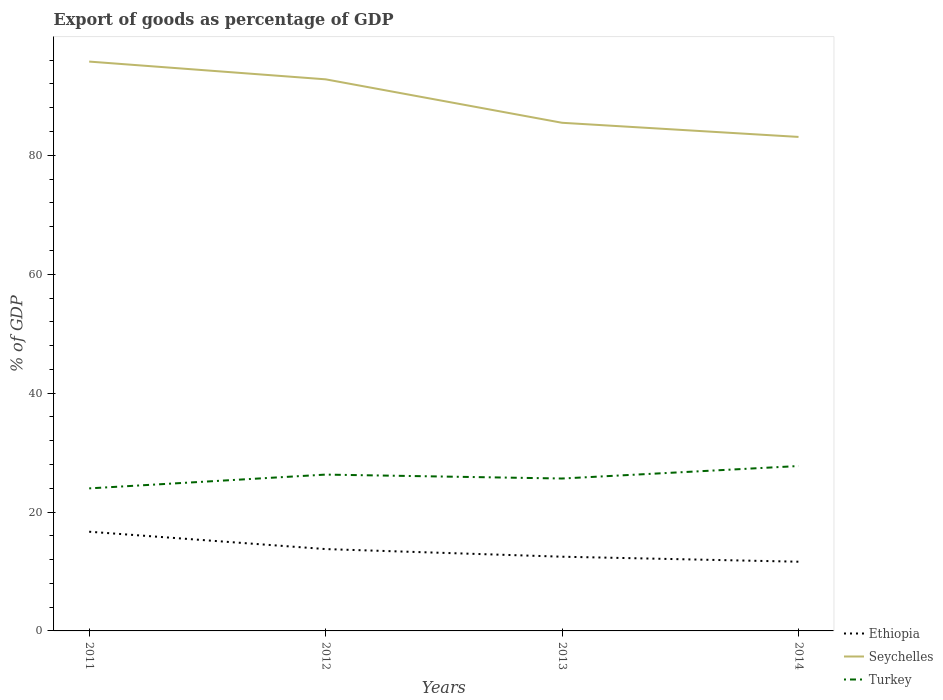Does the line corresponding to Seychelles intersect with the line corresponding to Ethiopia?
Your answer should be compact. No. Across all years, what is the maximum export of goods as percentage of GDP in Turkey?
Provide a succinct answer. 23.98. In which year was the export of goods as percentage of GDP in Turkey maximum?
Your answer should be compact. 2011. What is the total export of goods as percentage of GDP in Ethiopia in the graph?
Ensure brevity in your answer.  4.2. What is the difference between the highest and the second highest export of goods as percentage of GDP in Ethiopia?
Offer a very short reply. 5.05. Is the export of goods as percentage of GDP in Turkey strictly greater than the export of goods as percentage of GDP in Ethiopia over the years?
Your response must be concise. No. How many lines are there?
Give a very brief answer. 3. Does the graph contain any zero values?
Give a very brief answer. No. How many legend labels are there?
Offer a very short reply. 3. What is the title of the graph?
Provide a succinct answer. Export of goods as percentage of GDP. Does "Middle East & North Africa (developing only)" appear as one of the legend labels in the graph?
Provide a succinct answer. No. What is the label or title of the Y-axis?
Give a very brief answer. % of GDP. What is the % of GDP in Ethiopia in 2011?
Provide a short and direct response. 16.69. What is the % of GDP of Seychelles in 2011?
Provide a succinct answer. 95.77. What is the % of GDP of Turkey in 2011?
Ensure brevity in your answer.  23.98. What is the % of GDP of Ethiopia in 2012?
Provide a succinct answer. 13.77. What is the % of GDP in Seychelles in 2012?
Keep it short and to the point. 92.79. What is the % of GDP of Turkey in 2012?
Offer a very short reply. 26.3. What is the % of GDP in Ethiopia in 2013?
Provide a succinct answer. 12.48. What is the % of GDP of Seychelles in 2013?
Make the answer very short. 85.48. What is the % of GDP in Turkey in 2013?
Your answer should be compact. 25.64. What is the % of GDP of Ethiopia in 2014?
Offer a very short reply. 11.64. What is the % of GDP in Seychelles in 2014?
Give a very brief answer. 83.1. What is the % of GDP in Turkey in 2014?
Your answer should be compact. 27.74. Across all years, what is the maximum % of GDP of Ethiopia?
Keep it short and to the point. 16.69. Across all years, what is the maximum % of GDP in Seychelles?
Offer a terse response. 95.77. Across all years, what is the maximum % of GDP of Turkey?
Ensure brevity in your answer.  27.74. Across all years, what is the minimum % of GDP in Ethiopia?
Your answer should be compact. 11.64. Across all years, what is the minimum % of GDP in Seychelles?
Provide a succinct answer. 83.1. Across all years, what is the minimum % of GDP in Turkey?
Provide a succinct answer. 23.98. What is the total % of GDP in Ethiopia in the graph?
Your answer should be very brief. 54.58. What is the total % of GDP in Seychelles in the graph?
Your response must be concise. 357.13. What is the total % of GDP in Turkey in the graph?
Keep it short and to the point. 103.65. What is the difference between the % of GDP of Ethiopia in 2011 and that in 2012?
Your response must be concise. 2.92. What is the difference between the % of GDP of Seychelles in 2011 and that in 2012?
Your response must be concise. 2.98. What is the difference between the % of GDP of Turkey in 2011 and that in 2012?
Keep it short and to the point. -2.32. What is the difference between the % of GDP of Ethiopia in 2011 and that in 2013?
Provide a succinct answer. 4.2. What is the difference between the % of GDP of Seychelles in 2011 and that in 2013?
Your answer should be very brief. 10.29. What is the difference between the % of GDP of Turkey in 2011 and that in 2013?
Give a very brief answer. -1.66. What is the difference between the % of GDP of Ethiopia in 2011 and that in 2014?
Keep it short and to the point. 5.05. What is the difference between the % of GDP of Seychelles in 2011 and that in 2014?
Your answer should be very brief. 12.67. What is the difference between the % of GDP of Turkey in 2011 and that in 2014?
Your response must be concise. -3.76. What is the difference between the % of GDP of Ethiopia in 2012 and that in 2013?
Provide a succinct answer. 1.28. What is the difference between the % of GDP in Seychelles in 2012 and that in 2013?
Make the answer very short. 7.31. What is the difference between the % of GDP in Turkey in 2012 and that in 2013?
Your answer should be very brief. 0.66. What is the difference between the % of GDP of Ethiopia in 2012 and that in 2014?
Offer a very short reply. 2.13. What is the difference between the % of GDP of Seychelles in 2012 and that in 2014?
Make the answer very short. 9.69. What is the difference between the % of GDP in Turkey in 2012 and that in 2014?
Your response must be concise. -1.44. What is the difference between the % of GDP of Ethiopia in 2013 and that in 2014?
Your answer should be very brief. 0.84. What is the difference between the % of GDP in Seychelles in 2013 and that in 2014?
Your response must be concise. 2.38. What is the difference between the % of GDP of Turkey in 2013 and that in 2014?
Give a very brief answer. -2.1. What is the difference between the % of GDP of Ethiopia in 2011 and the % of GDP of Seychelles in 2012?
Your response must be concise. -76.1. What is the difference between the % of GDP of Ethiopia in 2011 and the % of GDP of Turkey in 2012?
Your answer should be very brief. -9.61. What is the difference between the % of GDP of Seychelles in 2011 and the % of GDP of Turkey in 2012?
Offer a terse response. 69.47. What is the difference between the % of GDP in Ethiopia in 2011 and the % of GDP in Seychelles in 2013?
Your answer should be compact. -68.79. What is the difference between the % of GDP in Ethiopia in 2011 and the % of GDP in Turkey in 2013?
Offer a very short reply. -8.95. What is the difference between the % of GDP of Seychelles in 2011 and the % of GDP of Turkey in 2013?
Your answer should be compact. 70.13. What is the difference between the % of GDP of Ethiopia in 2011 and the % of GDP of Seychelles in 2014?
Your answer should be very brief. -66.41. What is the difference between the % of GDP in Ethiopia in 2011 and the % of GDP in Turkey in 2014?
Make the answer very short. -11.05. What is the difference between the % of GDP in Seychelles in 2011 and the % of GDP in Turkey in 2014?
Keep it short and to the point. 68.03. What is the difference between the % of GDP of Ethiopia in 2012 and the % of GDP of Seychelles in 2013?
Give a very brief answer. -71.71. What is the difference between the % of GDP in Ethiopia in 2012 and the % of GDP in Turkey in 2013?
Make the answer very short. -11.87. What is the difference between the % of GDP in Seychelles in 2012 and the % of GDP in Turkey in 2013?
Give a very brief answer. 67.15. What is the difference between the % of GDP of Ethiopia in 2012 and the % of GDP of Seychelles in 2014?
Your response must be concise. -69.33. What is the difference between the % of GDP of Ethiopia in 2012 and the % of GDP of Turkey in 2014?
Offer a very short reply. -13.97. What is the difference between the % of GDP of Seychelles in 2012 and the % of GDP of Turkey in 2014?
Your answer should be very brief. 65.05. What is the difference between the % of GDP of Ethiopia in 2013 and the % of GDP of Seychelles in 2014?
Provide a short and direct response. -70.61. What is the difference between the % of GDP of Ethiopia in 2013 and the % of GDP of Turkey in 2014?
Make the answer very short. -15.25. What is the difference between the % of GDP of Seychelles in 2013 and the % of GDP of Turkey in 2014?
Offer a terse response. 57.74. What is the average % of GDP of Ethiopia per year?
Provide a short and direct response. 13.64. What is the average % of GDP in Seychelles per year?
Provide a succinct answer. 89.28. What is the average % of GDP of Turkey per year?
Your response must be concise. 25.91. In the year 2011, what is the difference between the % of GDP in Ethiopia and % of GDP in Seychelles?
Ensure brevity in your answer.  -79.08. In the year 2011, what is the difference between the % of GDP of Ethiopia and % of GDP of Turkey?
Your response must be concise. -7.29. In the year 2011, what is the difference between the % of GDP in Seychelles and % of GDP in Turkey?
Ensure brevity in your answer.  71.79. In the year 2012, what is the difference between the % of GDP of Ethiopia and % of GDP of Seychelles?
Offer a very short reply. -79.02. In the year 2012, what is the difference between the % of GDP of Ethiopia and % of GDP of Turkey?
Offer a very short reply. -12.53. In the year 2012, what is the difference between the % of GDP of Seychelles and % of GDP of Turkey?
Make the answer very short. 66.49. In the year 2013, what is the difference between the % of GDP of Ethiopia and % of GDP of Seychelles?
Ensure brevity in your answer.  -72.99. In the year 2013, what is the difference between the % of GDP of Ethiopia and % of GDP of Turkey?
Ensure brevity in your answer.  -13.15. In the year 2013, what is the difference between the % of GDP in Seychelles and % of GDP in Turkey?
Provide a short and direct response. 59.84. In the year 2014, what is the difference between the % of GDP in Ethiopia and % of GDP in Seychelles?
Offer a terse response. -71.45. In the year 2014, what is the difference between the % of GDP in Ethiopia and % of GDP in Turkey?
Provide a succinct answer. -16.1. In the year 2014, what is the difference between the % of GDP in Seychelles and % of GDP in Turkey?
Offer a terse response. 55.36. What is the ratio of the % of GDP in Ethiopia in 2011 to that in 2012?
Ensure brevity in your answer.  1.21. What is the ratio of the % of GDP in Seychelles in 2011 to that in 2012?
Give a very brief answer. 1.03. What is the ratio of the % of GDP in Turkey in 2011 to that in 2012?
Your answer should be very brief. 0.91. What is the ratio of the % of GDP in Ethiopia in 2011 to that in 2013?
Offer a very short reply. 1.34. What is the ratio of the % of GDP in Seychelles in 2011 to that in 2013?
Give a very brief answer. 1.12. What is the ratio of the % of GDP in Turkey in 2011 to that in 2013?
Provide a short and direct response. 0.94. What is the ratio of the % of GDP in Ethiopia in 2011 to that in 2014?
Give a very brief answer. 1.43. What is the ratio of the % of GDP of Seychelles in 2011 to that in 2014?
Your answer should be compact. 1.15. What is the ratio of the % of GDP in Turkey in 2011 to that in 2014?
Your answer should be very brief. 0.86. What is the ratio of the % of GDP in Ethiopia in 2012 to that in 2013?
Give a very brief answer. 1.1. What is the ratio of the % of GDP in Seychelles in 2012 to that in 2013?
Keep it short and to the point. 1.09. What is the ratio of the % of GDP in Turkey in 2012 to that in 2013?
Provide a succinct answer. 1.03. What is the ratio of the % of GDP of Ethiopia in 2012 to that in 2014?
Provide a succinct answer. 1.18. What is the ratio of the % of GDP of Seychelles in 2012 to that in 2014?
Give a very brief answer. 1.12. What is the ratio of the % of GDP in Turkey in 2012 to that in 2014?
Your answer should be compact. 0.95. What is the ratio of the % of GDP of Ethiopia in 2013 to that in 2014?
Your response must be concise. 1.07. What is the ratio of the % of GDP of Seychelles in 2013 to that in 2014?
Ensure brevity in your answer.  1.03. What is the ratio of the % of GDP of Turkey in 2013 to that in 2014?
Your response must be concise. 0.92. What is the difference between the highest and the second highest % of GDP in Ethiopia?
Ensure brevity in your answer.  2.92. What is the difference between the highest and the second highest % of GDP of Seychelles?
Give a very brief answer. 2.98. What is the difference between the highest and the second highest % of GDP of Turkey?
Keep it short and to the point. 1.44. What is the difference between the highest and the lowest % of GDP in Ethiopia?
Provide a short and direct response. 5.05. What is the difference between the highest and the lowest % of GDP in Seychelles?
Your answer should be compact. 12.67. What is the difference between the highest and the lowest % of GDP in Turkey?
Your answer should be very brief. 3.76. 